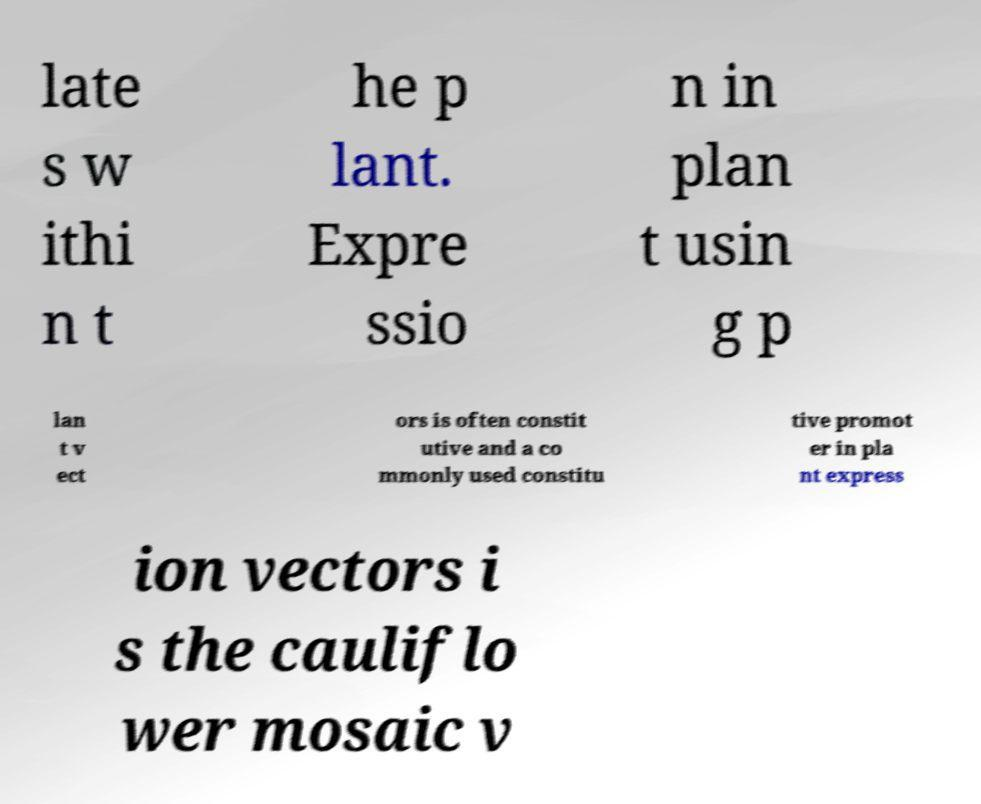Can you read and provide the text displayed in the image?This photo seems to have some interesting text. Can you extract and type it out for me? late s w ithi n t he p lant. Expre ssio n in plan t usin g p lan t v ect ors is often constit utive and a co mmonly used constitu tive promot er in pla nt express ion vectors i s the cauliflo wer mosaic v 